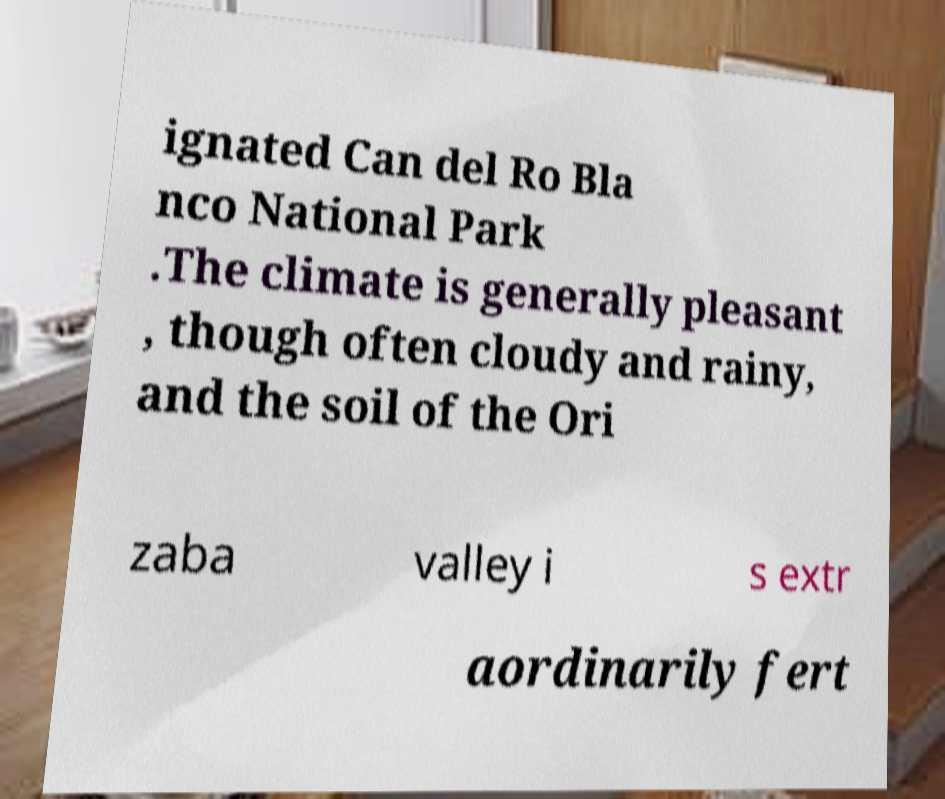Could you extract and type out the text from this image? ignated Can del Ro Bla nco National Park .The climate is generally pleasant , though often cloudy and rainy, and the soil of the Ori zaba valley i s extr aordinarily fert 